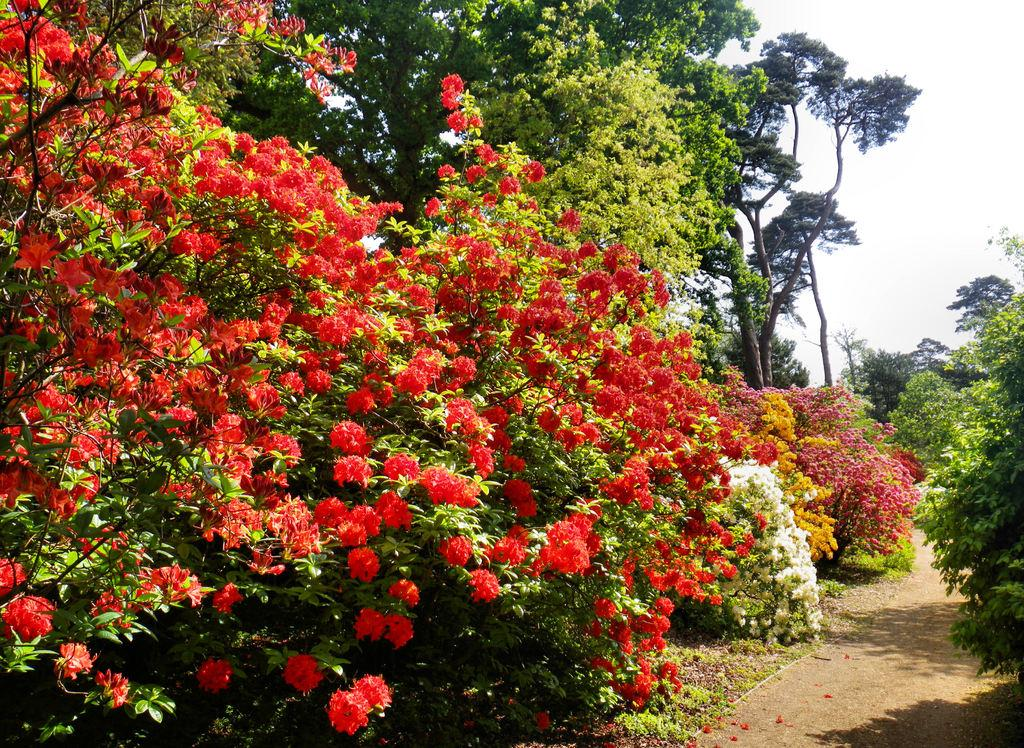What types of flowers can be seen on the plants in the image? There are plants with red, yellow, pink, and white flowers in the image. Can you describe the plants in the image? The plants have various colors of flowers, including red, yellow, pink, and white. What is visible in the background of the image? There are trees and the sky visible in the background of the image. What is the weight of the spark that caused the anger in the image? There is no spark or anger present in the image; it features plants with flowers and a background with trees and the sky. 